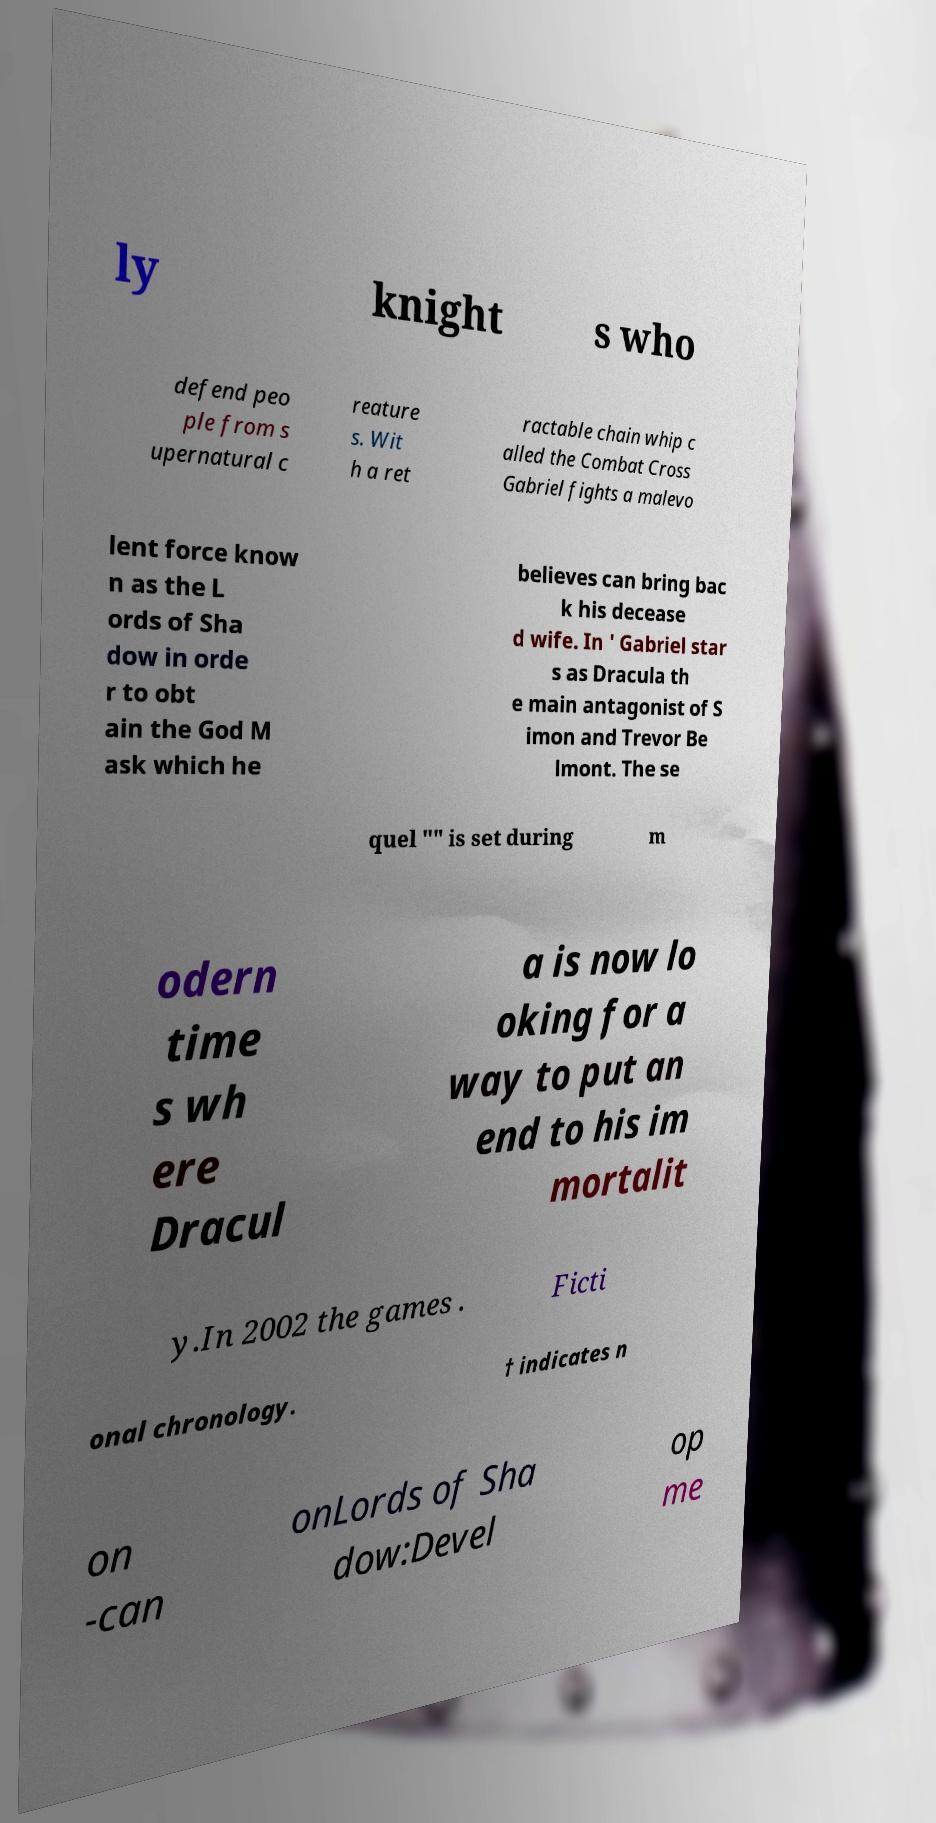Can you read and provide the text displayed in the image?This photo seems to have some interesting text. Can you extract and type it out for me? ly knight s who defend peo ple from s upernatural c reature s. Wit h a ret ractable chain whip c alled the Combat Cross Gabriel fights a malevo lent force know n as the L ords of Sha dow in orde r to obt ain the God M ask which he believes can bring bac k his decease d wife. In ' Gabriel star s as Dracula th e main antagonist of S imon and Trevor Be lmont. The se quel "" is set during m odern time s wh ere Dracul a is now lo oking for a way to put an end to his im mortalit y.In 2002 the games . Ficti onal chronology. † indicates n on -can onLords of Sha dow:Devel op me 